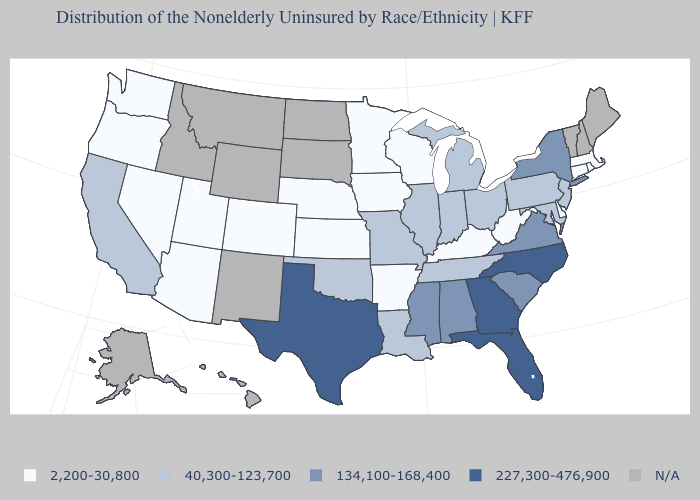Name the states that have a value in the range 2,200-30,800?
Quick response, please. Arizona, Arkansas, Colorado, Connecticut, Delaware, Iowa, Kansas, Kentucky, Massachusetts, Minnesota, Nebraska, Nevada, Oregon, Rhode Island, Utah, Washington, West Virginia, Wisconsin. Does Georgia have the highest value in the USA?
Keep it brief. Yes. What is the value of Ohio?
Concise answer only. 40,300-123,700. Name the states that have a value in the range 40,300-123,700?
Quick response, please. California, Illinois, Indiana, Louisiana, Maryland, Michigan, Missouri, New Jersey, Ohio, Oklahoma, Pennsylvania, Tennessee. Which states have the lowest value in the USA?
Quick response, please. Arizona, Arkansas, Colorado, Connecticut, Delaware, Iowa, Kansas, Kentucky, Massachusetts, Minnesota, Nebraska, Nevada, Oregon, Rhode Island, Utah, Washington, West Virginia, Wisconsin. Does Kentucky have the highest value in the USA?
Concise answer only. No. What is the lowest value in the Northeast?
Answer briefly. 2,200-30,800. Is the legend a continuous bar?
Keep it brief. No. Among the states that border Nevada , which have the lowest value?
Concise answer only. Arizona, Oregon, Utah. Which states hav the highest value in the South?
Answer briefly. Florida, Georgia, North Carolina, Texas. What is the lowest value in states that border Connecticut?
Give a very brief answer. 2,200-30,800. Does the map have missing data?
Short answer required. Yes. What is the value of Texas?
Quick response, please. 227,300-476,900. Name the states that have a value in the range 2,200-30,800?
Short answer required. Arizona, Arkansas, Colorado, Connecticut, Delaware, Iowa, Kansas, Kentucky, Massachusetts, Minnesota, Nebraska, Nevada, Oregon, Rhode Island, Utah, Washington, West Virginia, Wisconsin. 